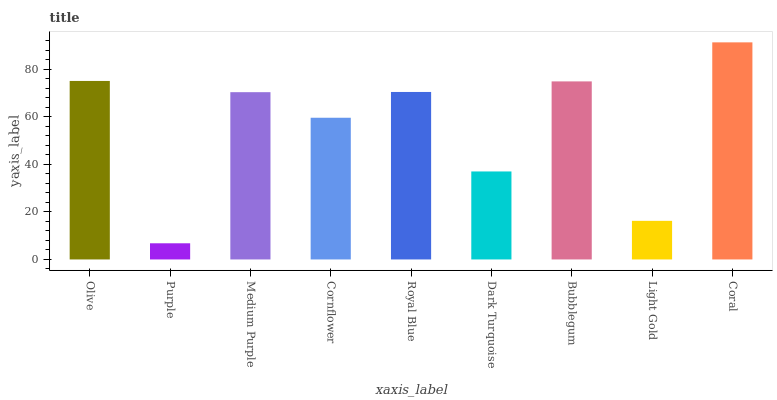Is Purple the minimum?
Answer yes or no. Yes. Is Coral the maximum?
Answer yes or no. Yes. Is Medium Purple the minimum?
Answer yes or no. No. Is Medium Purple the maximum?
Answer yes or no. No. Is Medium Purple greater than Purple?
Answer yes or no. Yes. Is Purple less than Medium Purple?
Answer yes or no. Yes. Is Purple greater than Medium Purple?
Answer yes or no. No. Is Medium Purple less than Purple?
Answer yes or no. No. Is Medium Purple the high median?
Answer yes or no. Yes. Is Medium Purple the low median?
Answer yes or no. Yes. Is Dark Turquoise the high median?
Answer yes or no. No. Is Dark Turquoise the low median?
Answer yes or no. No. 